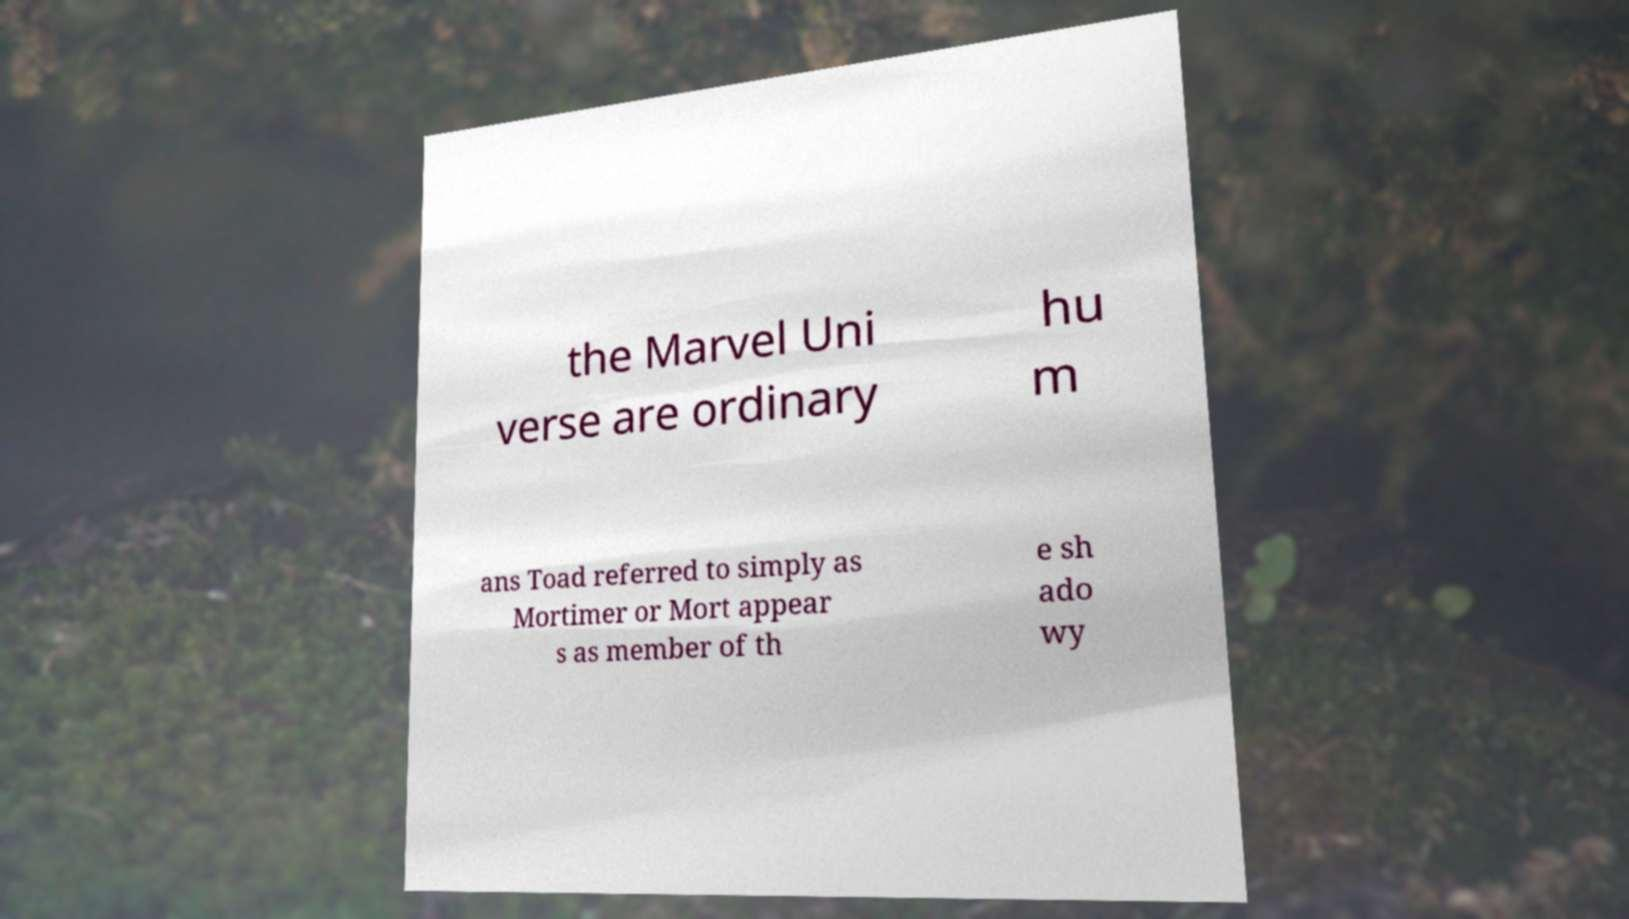For documentation purposes, I need the text within this image transcribed. Could you provide that? the Marvel Uni verse are ordinary hu m ans Toad referred to simply as Mortimer or Mort appear s as member of th e sh ado wy 